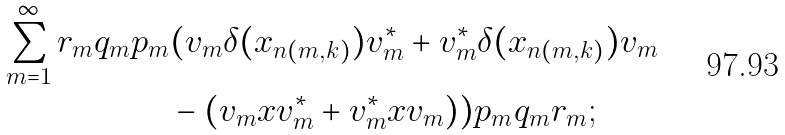<formula> <loc_0><loc_0><loc_500><loc_500>\sum _ { m = 1 } ^ { \infty } r _ { m } q _ { m } p _ { m } & ( v _ { m } \delta ( x _ { n ( m , k ) } ) v _ { m } ^ { * } + v _ { m } ^ { * } \delta ( x _ { n ( m , k ) } ) v _ { m } \\ & - ( v _ { m } x v _ { m } ^ { * } + v _ { m } ^ { * } x v _ { m } ) ) p _ { m } q _ { m } r _ { m } ;</formula> 